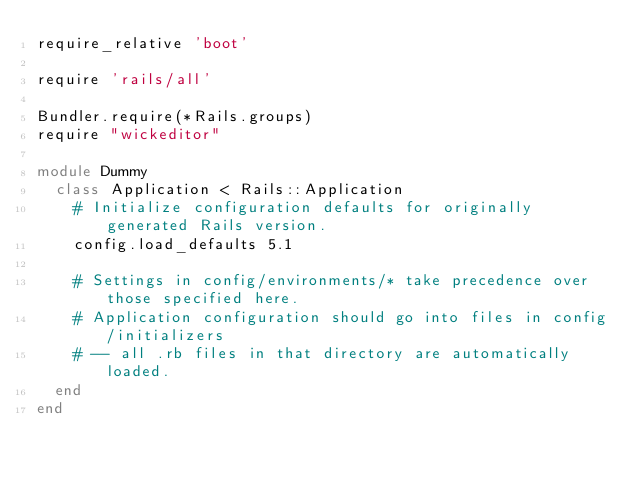Convert code to text. <code><loc_0><loc_0><loc_500><loc_500><_Ruby_>require_relative 'boot'

require 'rails/all'

Bundler.require(*Rails.groups)
require "wickeditor"

module Dummy
  class Application < Rails::Application
    # Initialize configuration defaults for originally generated Rails version.
    config.load_defaults 5.1

    # Settings in config/environments/* take precedence over those specified here.
    # Application configuration should go into files in config/initializers
    # -- all .rb files in that directory are automatically loaded.
  end
end

</code> 